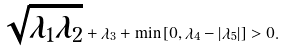<formula> <loc_0><loc_0><loc_500><loc_500>\sqrt { \lambda _ { 1 } \lambda _ { 2 } } + \lambda _ { 3 } + \min \left [ 0 , \lambda _ { 4 } - \left | \lambda _ { 5 } \right | \right ] > 0 .</formula> 